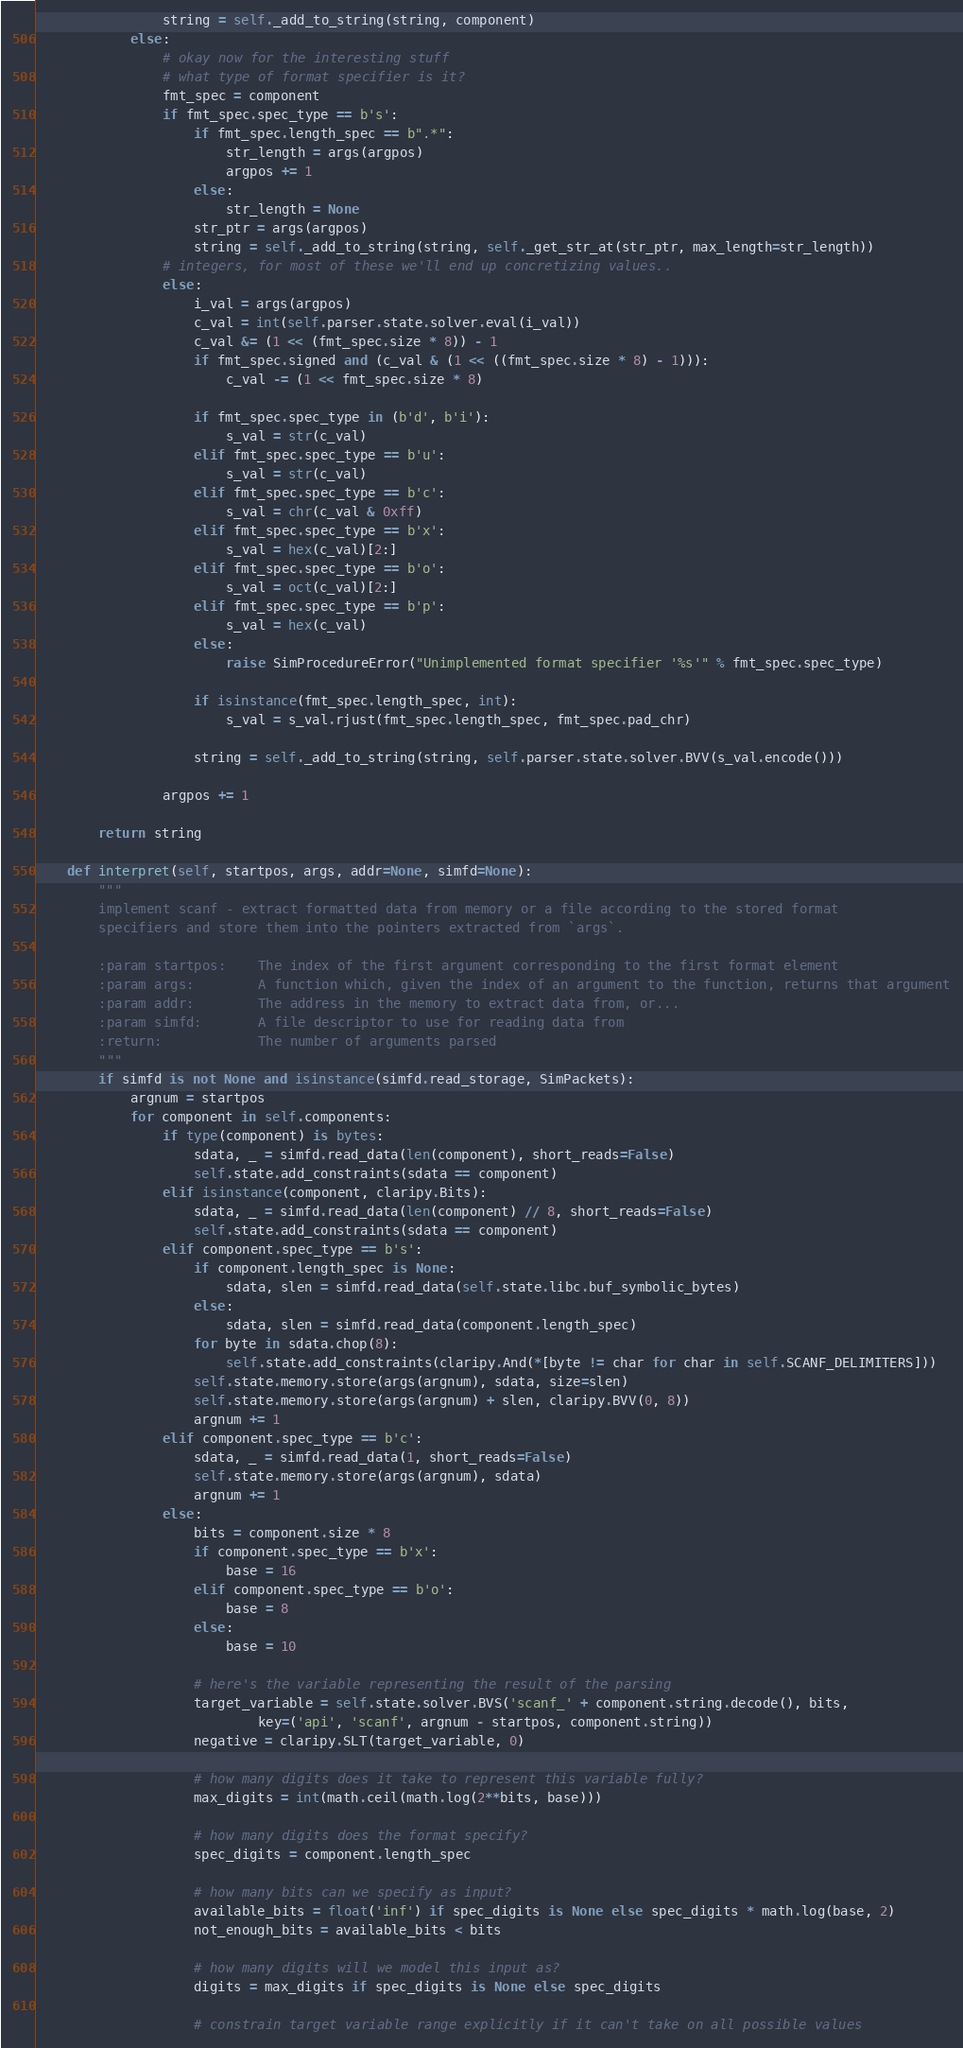<code> <loc_0><loc_0><loc_500><loc_500><_Python_>                string = self._add_to_string(string, component)
            else:
                # okay now for the interesting stuff
                # what type of format specifier is it?
                fmt_spec = component
                if fmt_spec.spec_type == b's':
                    if fmt_spec.length_spec == b".*":
                        str_length = args(argpos)
                        argpos += 1
                    else:
                        str_length = None
                    str_ptr = args(argpos)
                    string = self._add_to_string(string, self._get_str_at(str_ptr, max_length=str_length))
                # integers, for most of these we'll end up concretizing values..
                else:
                    i_val = args(argpos)
                    c_val = int(self.parser.state.solver.eval(i_val))
                    c_val &= (1 << (fmt_spec.size * 8)) - 1
                    if fmt_spec.signed and (c_val & (1 << ((fmt_spec.size * 8) - 1))):
                        c_val -= (1 << fmt_spec.size * 8)

                    if fmt_spec.spec_type in (b'd', b'i'):
                        s_val = str(c_val)
                    elif fmt_spec.spec_type == b'u':
                        s_val = str(c_val)
                    elif fmt_spec.spec_type == b'c':
                        s_val = chr(c_val & 0xff)
                    elif fmt_spec.spec_type == b'x':
                        s_val = hex(c_val)[2:]
                    elif fmt_spec.spec_type == b'o':
                        s_val = oct(c_val)[2:]
                    elif fmt_spec.spec_type == b'p':
                        s_val = hex(c_val)
                    else:
                        raise SimProcedureError("Unimplemented format specifier '%s'" % fmt_spec.spec_type)

                    if isinstance(fmt_spec.length_spec, int):
                        s_val = s_val.rjust(fmt_spec.length_spec, fmt_spec.pad_chr)

                    string = self._add_to_string(string, self.parser.state.solver.BVV(s_val.encode()))

                argpos += 1

        return string

    def interpret(self, startpos, args, addr=None, simfd=None):
        """
        implement scanf - extract formatted data from memory or a file according to the stored format
        specifiers and store them into the pointers extracted from `args`.

        :param startpos:    The index of the first argument corresponding to the first format element
        :param args:        A function which, given the index of an argument to the function, returns that argument
        :param addr:        The address in the memory to extract data from, or...
        :param simfd:       A file descriptor to use for reading data from
        :return:            The number of arguments parsed
        """
        if simfd is not None and isinstance(simfd.read_storage, SimPackets):
            argnum = startpos
            for component in self.components:
                if type(component) is bytes:
                    sdata, _ = simfd.read_data(len(component), short_reads=False)
                    self.state.add_constraints(sdata == component)
                elif isinstance(component, claripy.Bits):
                    sdata, _ = simfd.read_data(len(component) // 8, short_reads=False)
                    self.state.add_constraints(sdata == component)
                elif component.spec_type == b's':
                    if component.length_spec is None:
                        sdata, slen = simfd.read_data(self.state.libc.buf_symbolic_bytes)
                    else:
                        sdata, slen = simfd.read_data(component.length_spec)
                    for byte in sdata.chop(8):
                        self.state.add_constraints(claripy.And(*[byte != char for char in self.SCANF_DELIMITERS]))
                    self.state.memory.store(args(argnum), sdata, size=slen)
                    self.state.memory.store(args(argnum) + slen, claripy.BVV(0, 8))
                    argnum += 1
                elif component.spec_type == b'c':
                    sdata, _ = simfd.read_data(1, short_reads=False)
                    self.state.memory.store(args(argnum), sdata)
                    argnum += 1
                else:
                    bits = component.size * 8
                    if component.spec_type == b'x':
                        base = 16
                    elif component.spec_type == b'o':
                        base = 8
                    else:
                        base = 10

                    # here's the variable representing the result of the parsing
                    target_variable = self.state.solver.BVS('scanf_' + component.string.decode(), bits,
                            key=('api', 'scanf', argnum - startpos, component.string))
                    negative = claripy.SLT(target_variable, 0)

                    # how many digits does it take to represent this variable fully?
                    max_digits = int(math.ceil(math.log(2**bits, base)))

                    # how many digits does the format specify?
                    spec_digits = component.length_spec

                    # how many bits can we specify as input?
                    available_bits = float('inf') if spec_digits is None else spec_digits * math.log(base, 2)
                    not_enough_bits = available_bits < bits

                    # how many digits will we model this input as?
                    digits = max_digits if spec_digits is None else spec_digits

                    # constrain target variable range explicitly if it can't take on all possible values</code> 